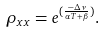Convert formula to latex. <formula><loc_0><loc_0><loc_500><loc_500>\rho _ { x x } = e ^ { ( \frac { - \Delta \nu } { \alpha T + \beta } ) } .</formula> 